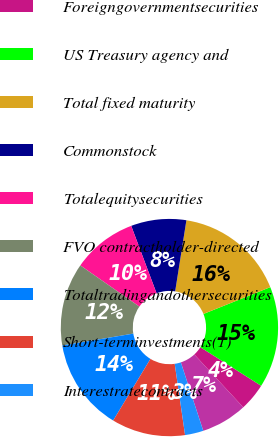Convert chart. <chart><loc_0><loc_0><loc_500><loc_500><pie_chart><fcel>RMBS<fcel>Foreigngovernmentsecurities<fcel>US Treasury agency and<fcel>Total fixed maturity<fcel>Commonstock<fcel>Totalequitysecurities<fcel>FVO contractholder-directed<fcel>Totaltradingandothersecurities<fcel>Short-terminvestments(1)<fcel>Interestratecontracts<nl><fcel>6.85%<fcel>4.11%<fcel>15.07%<fcel>16.44%<fcel>8.22%<fcel>9.59%<fcel>12.33%<fcel>13.7%<fcel>10.96%<fcel>2.74%<nl></chart> 